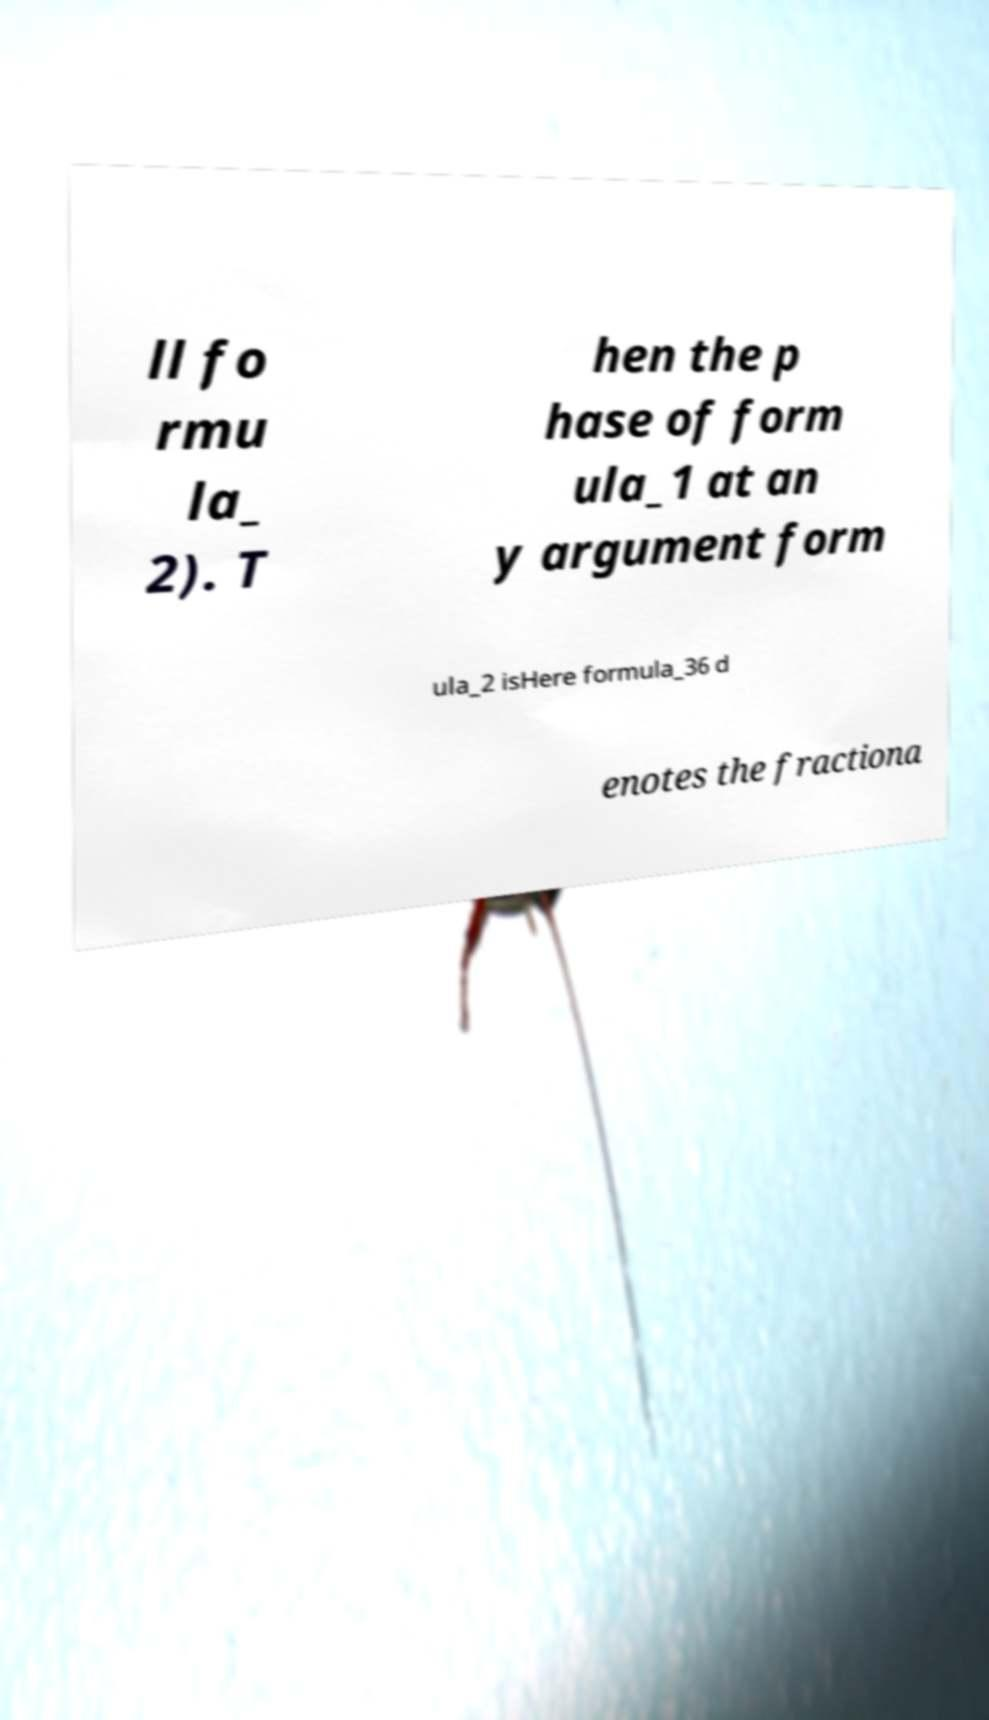Can you read and provide the text displayed in the image?This photo seems to have some interesting text. Can you extract and type it out for me? ll fo rmu la_ 2). T hen the p hase of form ula_1 at an y argument form ula_2 isHere formula_36 d enotes the fractiona 